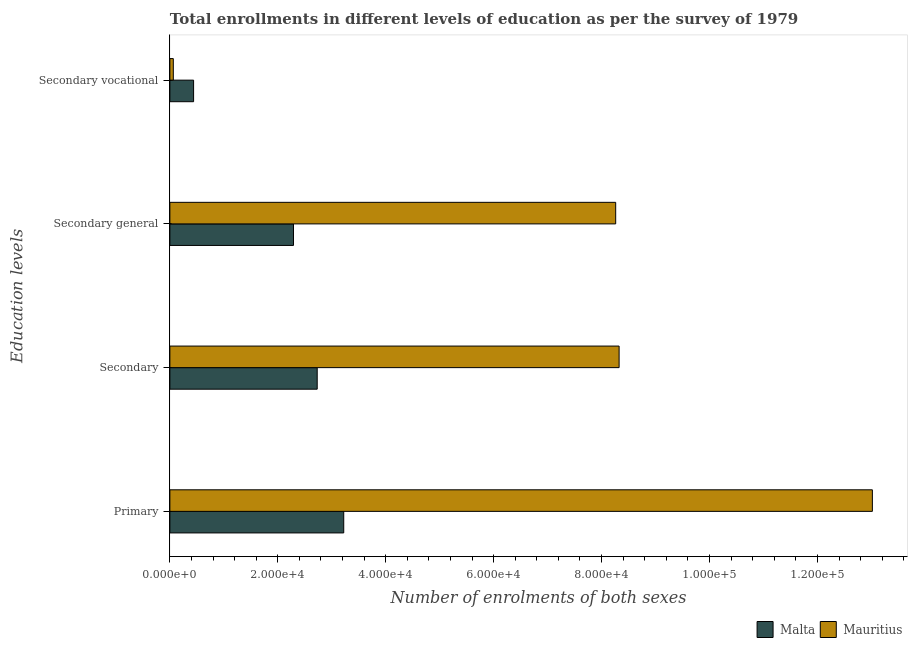How many different coloured bars are there?
Provide a succinct answer. 2. How many groups of bars are there?
Your answer should be very brief. 4. Are the number of bars per tick equal to the number of legend labels?
Make the answer very short. Yes. Are the number of bars on each tick of the Y-axis equal?
Your response must be concise. Yes. How many bars are there on the 3rd tick from the bottom?
Your answer should be compact. 2. What is the label of the 3rd group of bars from the top?
Your answer should be compact. Secondary. What is the number of enrolments in secondary education in Mauritius?
Offer a terse response. 8.33e+04. Across all countries, what is the maximum number of enrolments in secondary vocational education?
Provide a short and direct response. 4395. Across all countries, what is the minimum number of enrolments in primary education?
Your answer should be compact. 3.22e+04. In which country was the number of enrolments in secondary general education maximum?
Offer a very short reply. Mauritius. In which country was the number of enrolments in secondary general education minimum?
Keep it short and to the point. Malta. What is the total number of enrolments in primary education in the graph?
Provide a succinct answer. 1.62e+05. What is the difference between the number of enrolments in primary education in Mauritius and that in Malta?
Your answer should be compact. 9.80e+04. What is the difference between the number of enrolments in secondary general education in Mauritius and the number of enrolments in secondary vocational education in Malta?
Provide a succinct answer. 7.82e+04. What is the average number of enrolments in secondary general education per country?
Offer a very short reply. 5.28e+04. What is the difference between the number of enrolments in secondary education and number of enrolments in secondary vocational education in Malta?
Your answer should be very brief. 2.29e+04. In how many countries, is the number of enrolments in primary education greater than 84000 ?
Ensure brevity in your answer.  1. What is the ratio of the number of enrolments in secondary general education in Mauritius to that in Malta?
Your response must be concise. 3.61. Is the difference between the number of enrolments in secondary general education in Malta and Mauritius greater than the difference between the number of enrolments in secondary education in Malta and Mauritius?
Give a very brief answer. No. What is the difference between the highest and the second highest number of enrolments in secondary education?
Ensure brevity in your answer.  5.60e+04. What is the difference between the highest and the lowest number of enrolments in secondary vocational education?
Provide a succinct answer. 3759. What does the 1st bar from the top in Secondary vocational represents?
Keep it short and to the point. Mauritius. What does the 1st bar from the bottom in Secondary vocational represents?
Give a very brief answer. Malta. How many bars are there?
Your answer should be very brief. 8. Are all the bars in the graph horizontal?
Provide a succinct answer. Yes. How many countries are there in the graph?
Provide a succinct answer. 2. What is the difference between two consecutive major ticks on the X-axis?
Ensure brevity in your answer.  2.00e+04. Does the graph contain grids?
Offer a very short reply. No. How are the legend labels stacked?
Make the answer very short. Horizontal. What is the title of the graph?
Your response must be concise. Total enrollments in different levels of education as per the survey of 1979. What is the label or title of the X-axis?
Your answer should be compact. Number of enrolments of both sexes. What is the label or title of the Y-axis?
Provide a succinct answer. Education levels. What is the Number of enrolments of both sexes of Malta in Primary?
Your response must be concise. 3.22e+04. What is the Number of enrolments of both sexes of Mauritius in Primary?
Provide a short and direct response. 1.30e+05. What is the Number of enrolments of both sexes of Malta in Secondary?
Provide a succinct answer. 2.73e+04. What is the Number of enrolments of both sexes in Mauritius in Secondary?
Provide a succinct answer. 8.33e+04. What is the Number of enrolments of both sexes in Malta in Secondary general?
Ensure brevity in your answer.  2.29e+04. What is the Number of enrolments of both sexes of Mauritius in Secondary general?
Your answer should be compact. 8.26e+04. What is the Number of enrolments of both sexes in Malta in Secondary vocational?
Offer a terse response. 4395. What is the Number of enrolments of both sexes of Mauritius in Secondary vocational?
Ensure brevity in your answer.  636. Across all Education levels, what is the maximum Number of enrolments of both sexes of Malta?
Offer a terse response. 3.22e+04. Across all Education levels, what is the maximum Number of enrolments of both sexes in Mauritius?
Your response must be concise. 1.30e+05. Across all Education levels, what is the minimum Number of enrolments of both sexes of Malta?
Keep it short and to the point. 4395. Across all Education levels, what is the minimum Number of enrolments of both sexes in Mauritius?
Provide a short and direct response. 636. What is the total Number of enrolments of both sexes in Malta in the graph?
Make the answer very short. 8.68e+04. What is the total Number of enrolments of both sexes in Mauritius in the graph?
Give a very brief answer. 2.97e+05. What is the difference between the Number of enrolments of both sexes of Malta in Primary and that in Secondary?
Your answer should be compact. 4916. What is the difference between the Number of enrolments of both sexes in Mauritius in Primary and that in Secondary?
Provide a short and direct response. 4.69e+04. What is the difference between the Number of enrolments of both sexes of Malta in Primary and that in Secondary general?
Offer a terse response. 9311. What is the difference between the Number of enrolments of both sexes of Mauritius in Primary and that in Secondary general?
Provide a short and direct response. 4.76e+04. What is the difference between the Number of enrolments of both sexes of Malta in Primary and that in Secondary vocational?
Make the answer very short. 2.78e+04. What is the difference between the Number of enrolments of both sexes of Mauritius in Primary and that in Secondary vocational?
Provide a short and direct response. 1.30e+05. What is the difference between the Number of enrolments of both sexes of Malta in Secondary and that in Secondary general?
Your answer should be compact. 4395. What is the difference between the Number of enrolments of both sexes of Mauritius in Secondary and that in Secondary general?
Your answer should be very brief. 636. What is the difference between the Number of enrolments of both sexes in Malta in Secondary and that in Secondary vocational?
Ensure brevity in your answer.  2.29e+04. What is the difference between the Number of enrolments of both sexes in Mauritius in Secondary and that in Secondary vocational?
Offer a very short reply. 8.26e+04. What is the difference between the Number of enrolments of both sexes in Malta in Secondary general and that in Secondary vocational?
Your answer should be compact. 1.85e+04. What is the difference between the Number of enrolments of both sexes of Mauritius in Secondary general and that in Secondary vocational?
Keep it short and to the point. 8.20e+04. What is the difference between the Number of enrolments of both sexes of Malta in Primary and the Number of enrolments of both sexes of Mauritius in Secondary?
Your response must be concise. -5.10e+04. What is the difference between the Number of enrolments of both sexes of Malta in Primary and the Number of enrolments of both sexes of Mauritius in Secondary general?
Keep it short and to the point. -5.04e+04. What is the difference between the Number of enrolments of both sexes in Malta in Primary and the Number of enrolments of both sexes in Mauritius in Secondary vocational?
Provide a succinct answer. 3.16e+04. What is the difference between the Number of enrolments of both sexes in Malta in Secondary and the Number of enrolments of both sexes in Mauritius in Secondary general?
Ensure brevity in your answer.  -5.53e+04. What is the difference between the Number of enrolments of both sexes of Malta in Secondary and the Number of enrolments of both sexes of Mauritius in Secondary vocational?
Your response must be concise. 2.67e+04. What is the difference between the Number of enrolments of both sexes of Malta in Secondary general and the Number of enrolments of both sexes of Mauritius in Secondary vocational?
Keep it short and to the point. 2.23e+04. What is the average Number of enrolments of both sexes in Malta per Education levels?
Offer a terse response. 2.17e+04. What is the average Number of enrolments of both sexes of Mauritius per Education levels?
Provide a short and direct response. 7.42e+04. What is the difference between the Number of enrolments of both sexes in Malta and Number of enrolments of both sexes in Mauritius in Primary?
Provide a short and direct response. -9.80e+04. What is the difference between the Number of enrolments of both sexes of Malta and Number of enrolments of both sexes of Mauritius in Secondary?
Ensure brevity in your answer.  -5.60e+04. What is the difference between the Number of enrolments of both sexes in Malta and Number of enrolments of both sexes in Mauritius in Secondary general?
Provide a succinct answer. -5.97e+04. What is the difference between the Number of enrolments of both sexes of Malta and Number of enrolments of both sexes of Mauritius in Secondary vocational?
Ensure brevity in your answer.  3759. What is the ratio of the Number of enrolments of both sexes in Malta in Primary to that in Secondary?
Your answer should be compact. 1.18. What is the ratio of the Number of enrolments of both sexes in Mauritius in Primary to that in Secondary?
Your response must be concise. 1.56. What is the ratio of the Number of enrolments of both sexes in Malta in Primary to that in Secondary general?
Ensure brevity in your answer.  1.41. What is the ratio of the Number of enrolments of both sexes of Mauritius in Primary to that in Secondary general?
Your answer should be very brief. 1.58. What is the ratio of the Number of enrolments of both sexes of Malta in Primary to that in Secondary vocational?
Ensure brevity in your answer.  7.33. What is the ratio of the Number of enrolments of both sexes in Mauritius in Primary to that in Secondary vocational?
Give a very brief answer. 204.69. What is the ratio of the Number of enrolments of both sexes in Malta in Secondary to that in Secondary general?
Keep it short and to the point. 1.19. What is the ratio of the Number of enrolments of both sexes of Mauritius in Secondary to that in Secondary general?
Your response must be concise. 1.01. What is the ratio of the Number of enrolments of both sexes of Malta in Secondary to that in Secondary vocational?
Your response must be concise. 6.21. What is the ratio of the Number of enrolments of both sexes in Mauritius in Secondary to that in Secondary vocational?
Offer a terse response. 130.9. What is the ratio of the Number of enrolments of both sexes of Malta in Secondary general to that in Secondary vocational?
Give a very brief answer. 5.21. What is the ratio of the Number of enrolments of both sexes in Mauritius in Secondary general to that in Secondary vocational?
Give a very brief answer. 129.9. What is the difference between the highest and the second highest Number of enrolments of both sexes of Malta?
Your answer should be compact. 4916. What is the difference between the highest and the second highest Number of enrolments of both sexes of Mauritius?
Provide a succinct answer. 4.69e+04. What is the difference between the highest and the lowest Number of enrolments of both sexes in Malta?
Ensure brevity in your answer.  2.78e+04. What is the difference between the highest and the lowest Number of enrolments of both sexes of Mauritius?
Your answer should be very brief. 1.30e+05. 